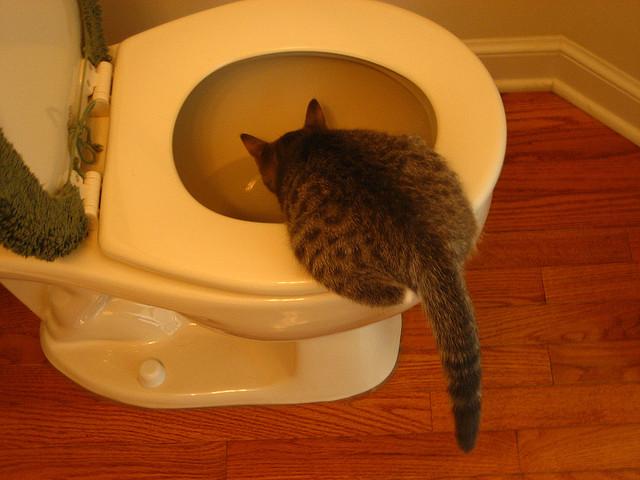Is the photo not disgusting?
Write a very short answer. No. How safe is it to drink from this fixture?
Short answer required. Not safe. What is the cat trying to consume?
Write a very short answer. Water. 